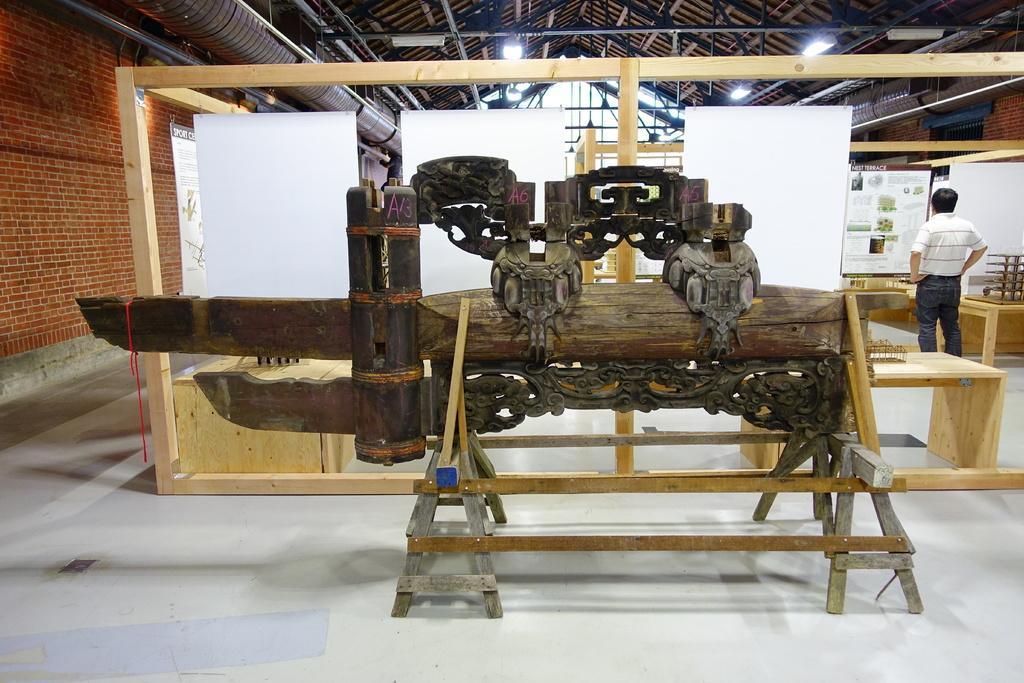How would you summarize this image in a sentence or two? In this image in the front there is an object which is made up of wood. In the background there are boards which are white in colour and there is a man standing and on the top there are lights hanging. On the left side there is a wall. 